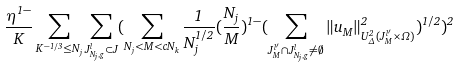Convert formula to latex. <formula><loc_0><loc_0><loc_500><loc_500>\frac { \eta ^ { 1 - } } { K } \sum _ { K ^ { - 1 / 3 } \leq N _ { j } } \sum _ { J _ { N _ { j } , g } ^ { l } \subset J } ( \sum _ { N _ { j } < M < c N _ { k } } \frac { 1 } { N _ { j } ^ { 1 / 2 } } ( \frac { N _ { j } } { M } ) ^ { 1 - } ( \sum _ { J _ { M } ^ { l ^ { \prime } } \cap J _ { N _ { j } , g } ^ { l } \neq \emptyset } \| u _ { M } \| _ { U _ { \Delta } ^ { 2 } ( J _ { M } ^ { l ^ { \prime } } \times \Omega ) } ^ { 2 } ) ^ { 1 / 2 } ) ^ { 2 }</formula> 